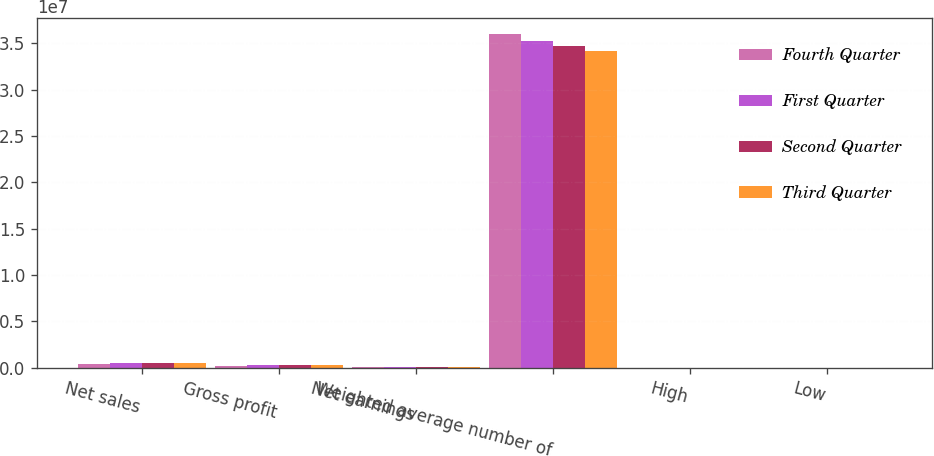<chart> <loc_0><loc_0><loc_500><loc_500><stacked_bar_chart><ecel><fcel>Net sales<fcel>Gross profit<fcel>Net earnings<fcel>Weighted average number of<fcel>High<fcel>Low<nl><fcel>Fourth Quarter<fcel>438955<fcel>221152<fcel>38279<fcel>3.59938e+07<fcel>112.37<fcel>87.51<nl><fcel>First Quarter<fcel>515605<fcel>259011<fcel>48851<fcel>3.53208e+07<fcel>105.01<fcel>94.05<nl><fcel>Second Quarter<fcel>509097<fcel>248680<fcel>52724<fcel>3.47278e+07<fcel>109.16<fcel>92.6<nl><fcel>Third Quarter<fcel>509687<fcel>264238<fcel>62924<fcel>3.41531e+07<fcel>98.33<fcel>60.64<nl></chart> 